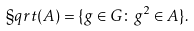<formula> <loc_0><loc_0><loc_500><loc_500>\S q r t ( A ) = \{ g \in G \colon g ^ { 2 } \in A \} .</formula> 